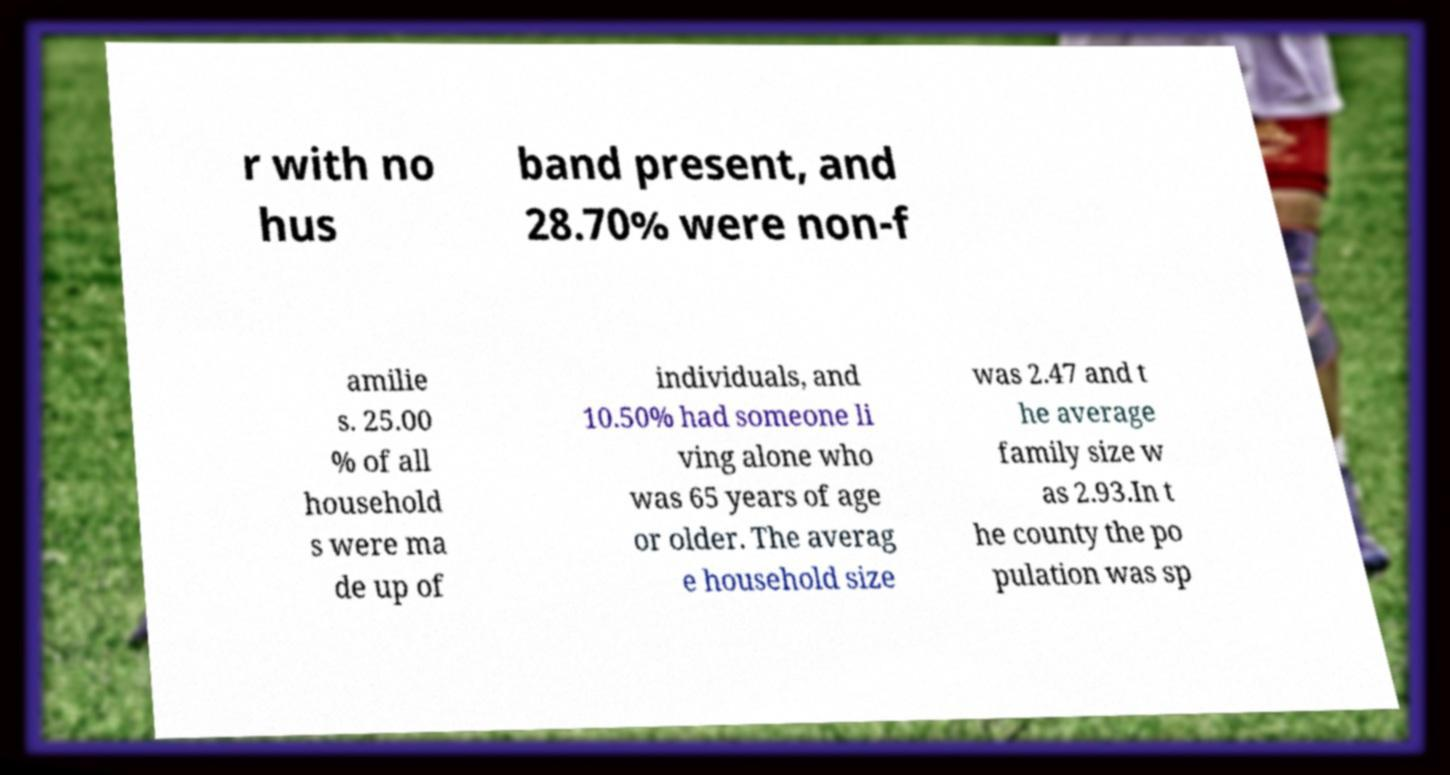I need the written content from this picture converted into text. Can you do that? r with no hus band present, and 28.70% were non-f amilie s. 25.00 % of all household s were ma de up of individuals, and 10.50% had someone li ving alone who was 65 years of age or older. The averag e household size was 2.47 and t he average family size w as 2.93.In t he county the po pulation was sp 